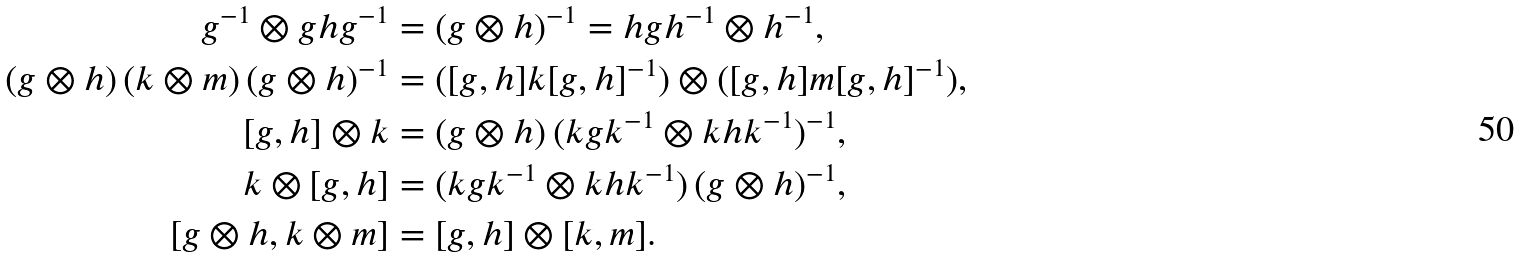<formula> <loc_0><loc_0><loc_500><loc_500>g ^ { - 1 } \otimes g h g ^ { - 1 } & = ( g \otimes h ) ^ { - 1 } = h g h ^ { - 1 } \otimes h ^ { - 1 } , \\ ( g \otimes h ) \, ( k \otimes m ) \, ( g \otimes h ) ^ { - 1 } & = ( [ g , h ] k [ g , h ] ^ { - 1 } ) \otimes ( [ g , h ] m [ g , h ] ^ { - 1 } ) , \\ [ g , h ] \otimes k & = ( g \otimes h ) \, ( k g k ^ { - 1 } \otimes k h k ^ { - 1 } ) ^ { - 1 } , \\ k \otimes [ g , h ] & = ( k g k ^ { - 1 } \otimes k h k ^ { - 1 } ) \, ( g \otimes h ) ^ { - 1 } , \\ [ g \otimes h , k \otimes m ] & = [ g , h ] \otimes [ k , m ] .</formula> 